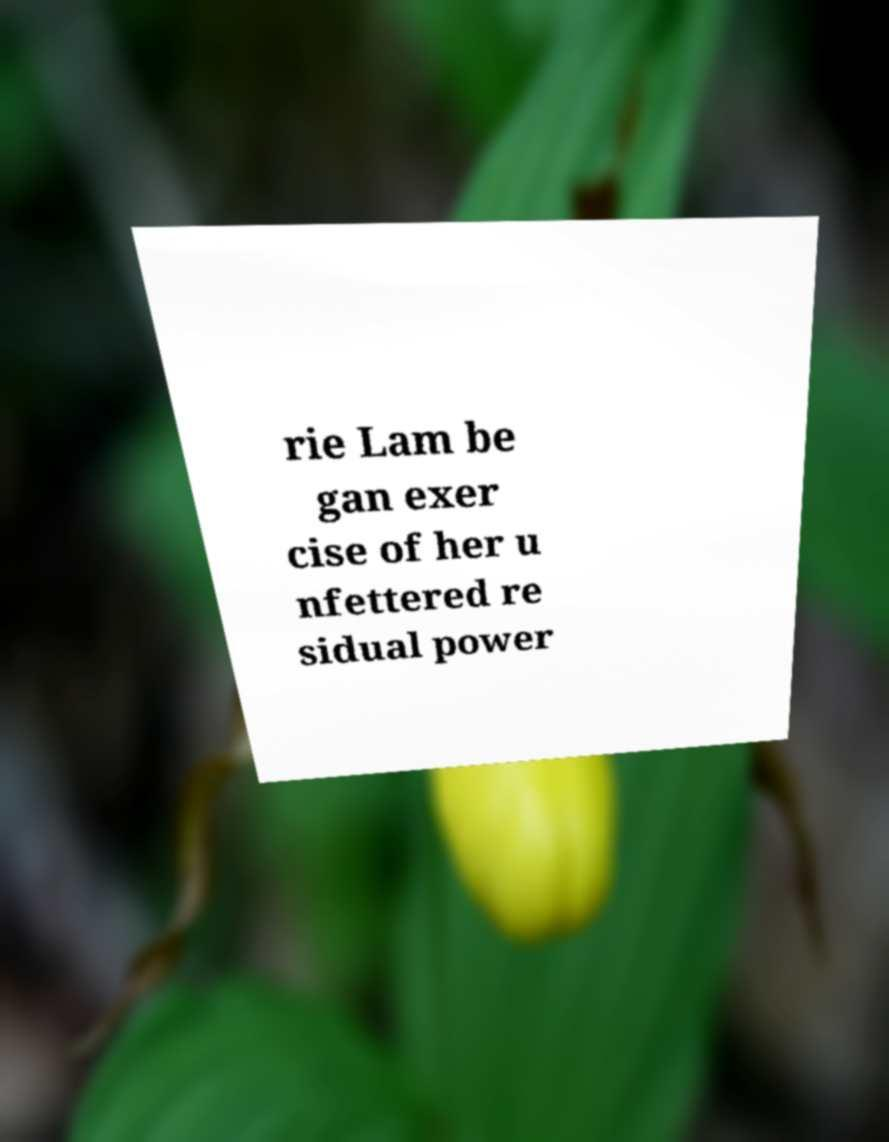Can you accurately transcribe the text from the provided image for me? rie Lam be gan exer cise of her u nfettered re sidual power 